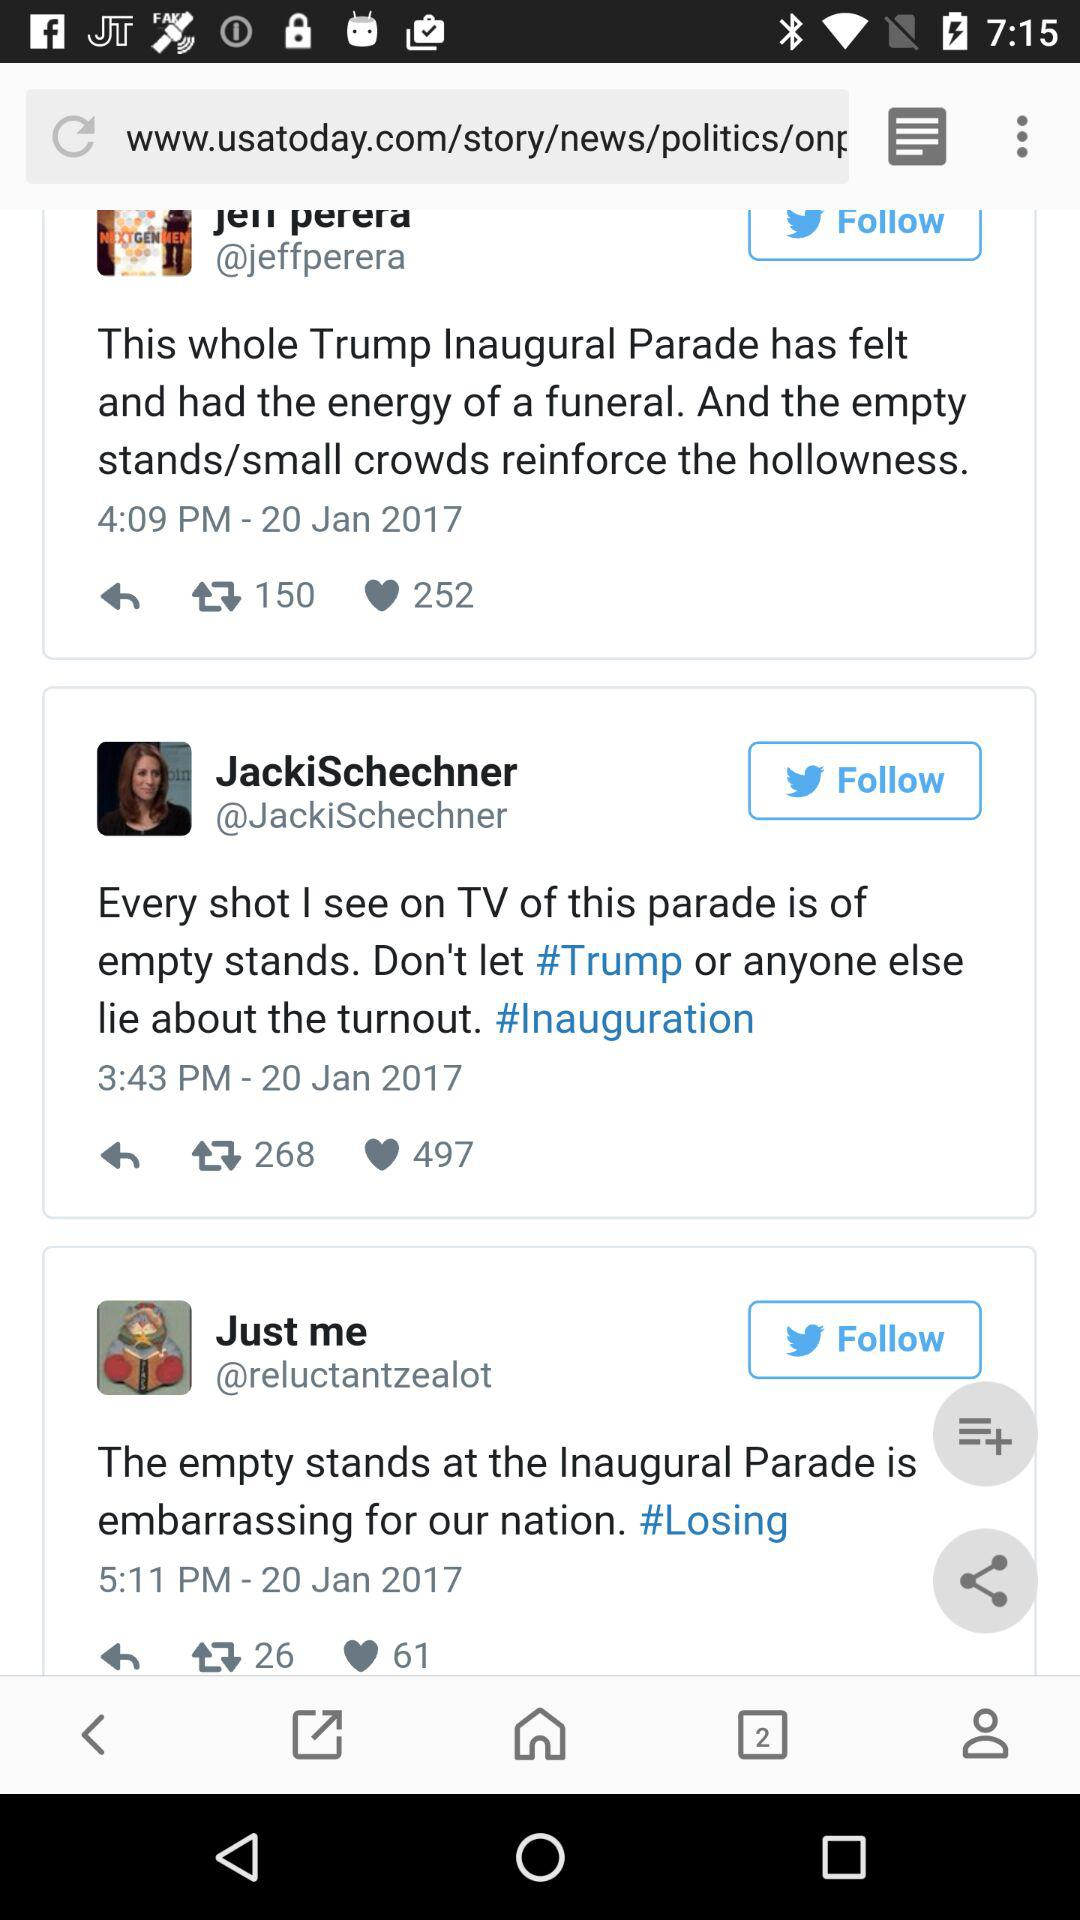How many messages are there?
When the provided information is insufficient, respond with <no answer>. <no answer> 